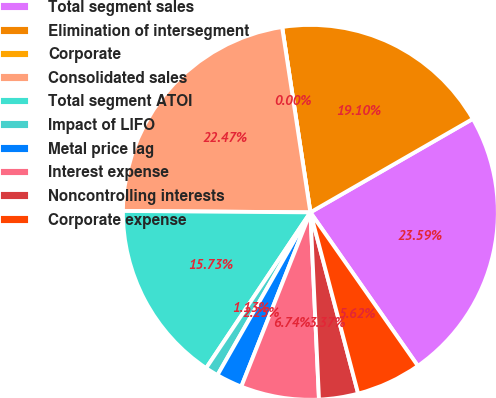Convert chart. <chart><loc_0><loc_0><loc_500><loc_500><pie_chart><fcel>Total segment sales<fcel>Elimination of intersegment<fcel>Corporate<fcel>Consolidated sales<fcel>Total segment ATOI<fcel>Impact of LIFO<fcel>Metal price lag<fcel>Interest expense<fcel>Noncontrolling interests<fcel>Corporate expense<nl><fcel>23.59%<fcel>19.1%<fcel>0.0%<fcel>22.47%<fcel>15.73%<fcel>1.13%<fcel>2.25%<fcel>6.74%<fcel>3.37%<fcel>5.62%<nl></chart> 